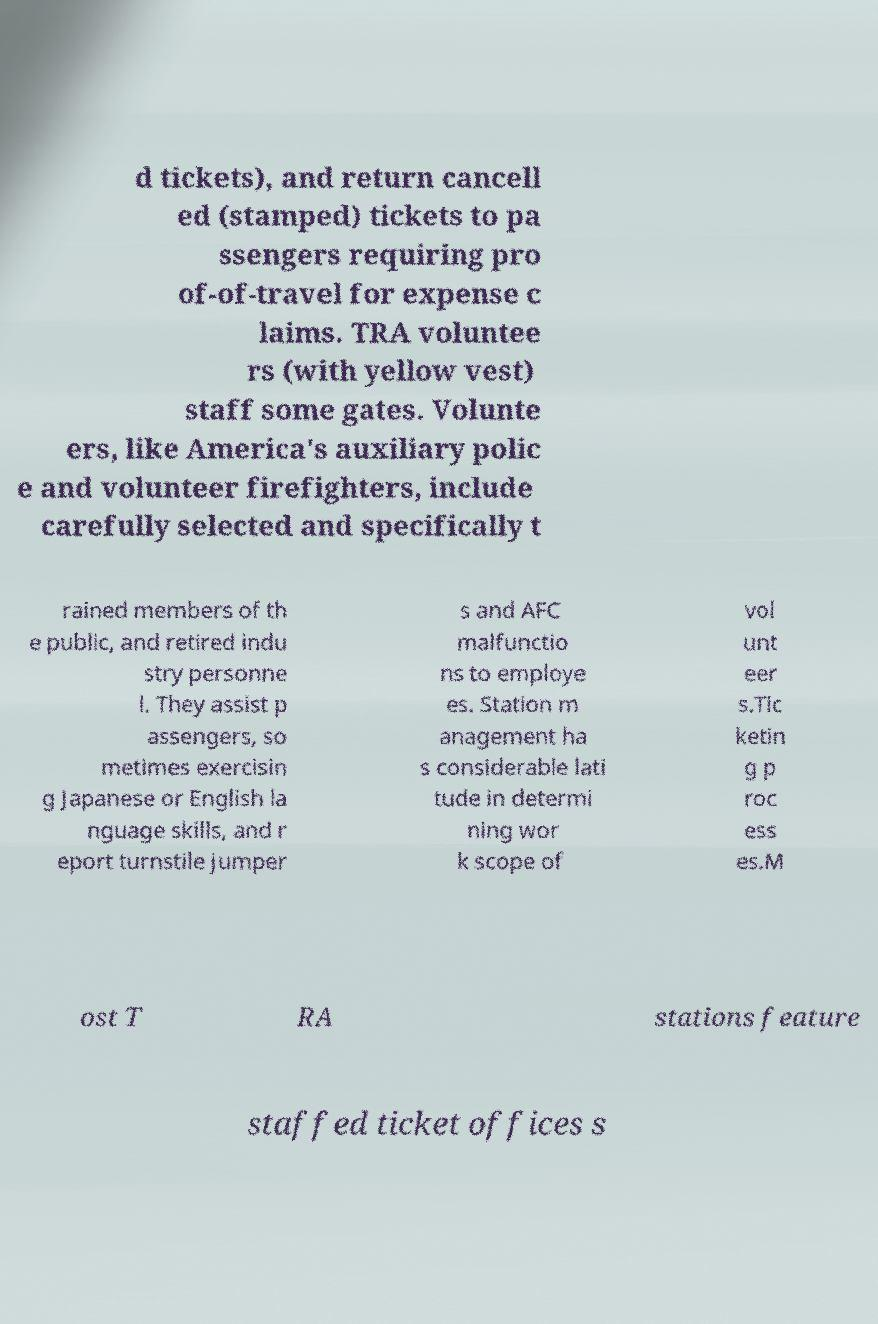There's text embedded in this image that I need extracted. Can you transcribe it verbatim? d tickets), and return cancell ed (stamped) tickets to pa ssengers requiring pro of-of-travel for expense c laims. TRA voluntee rs (with yellow vest) staff some gates. Volunte ers, like America's auxiliary polic e and volunteer firefighters, include carefully selected and specifically t rained members of th e public, and retired indu stry personne l. They assist p assengers, so metimes exercisin g Japanese or English la nguage skills, and r eport turnstile jumper s and AFC malfunctio ns to employe es. Station m anagement ha s considerable lati tude in determi ning wor k scope of vol unt eer s.Tic ketin g p roc ess es.M ost T RA stations feature staffed ticket offices s 